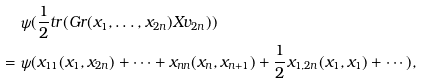<formula> <loc_0><loc_0><loc_500><loc_500>& \ \psi ( \frac { 1 } { 2 } t r ( G r ( x _ { 1 } , \dots , x _ { 2 n } ) X v _ { 2 n } ) ) \\ = & \ \psi ( x _ { 1 1 } ( x _ { 1 } , x _ { 2 n } ) + \cdots + x _ { n n } ( x _ { n } , x _ { n + 1 } ) + \frac { 1 } { 2 } x _ { 1 , 2 n } ( x _ { 1 } , x _ { 1 } ) + \cdots ) ,</formula> 